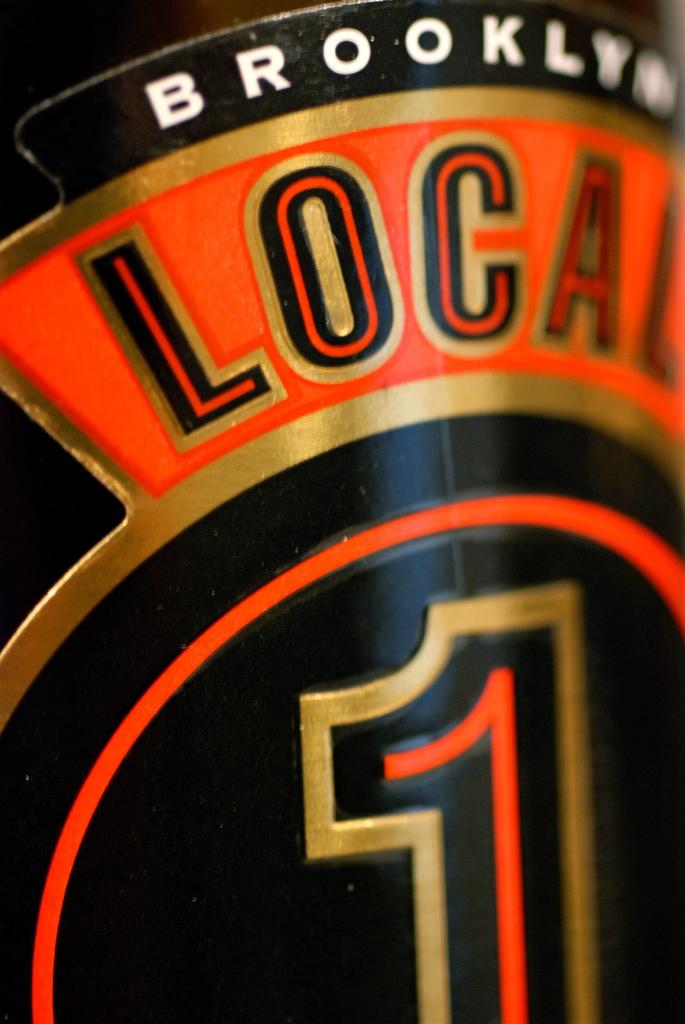What is present on the bottle in the image? There is text on a bottle in the image. What type of humor can be seen on the boy's face during breakfast in the image? There is no boy or breakfast present in the image; it only features a bottle with text on it. 